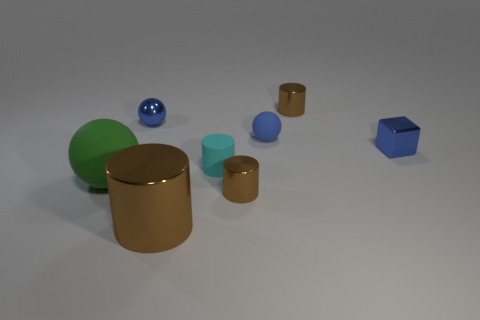Subtract all gray blocks. How many brown cylinders are left? 3 Add 1 tiny brown things. How many objects exist? 9 Subtract all balls. How many objects are left? 5 Subtract all spheres. Subtract all tiny brown things. How many objects are left? 3 Add 5 big green matte objects. How many big green matte objects are left? 6 Add 2 large metallic cylinders. How many large metallic cylinders exist? 3 Subtract 0 yellow balls. How many objects are left? 8 